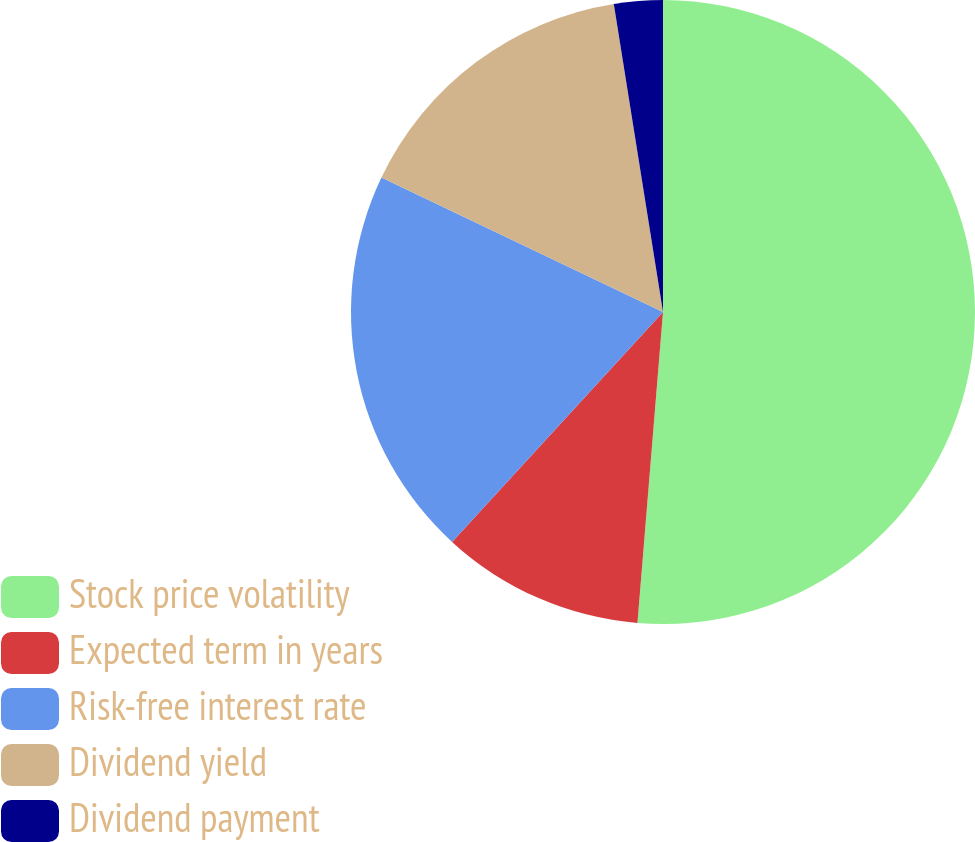Convert chart to OTSL. <chart><loc_0><loc_0><loc_500><loc_500><pie_chart><fcel>Stock price volatility<fcel>Expected term in years<fcel>Risk-free interest rate<fcel>Dividend yield<fcel>Dividend payment<nl><fcel>51.3%<fcel>10.51%<fcel>20.27%<fcel>15.39%<fcel>2.52%<nl></chart> 